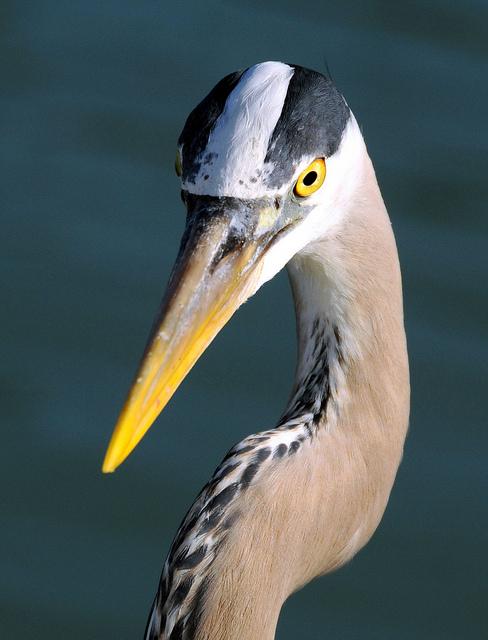What type of bird is this?
Keep it brief. Stork. What color is the background?
Give a very brief answer. Blue. What color is the bird's eye?
Quick response, please. Yellow. What bird is this?
Give a very brief answer. Crane. What kind of animal is shown?
Keep it brief. Bird. 